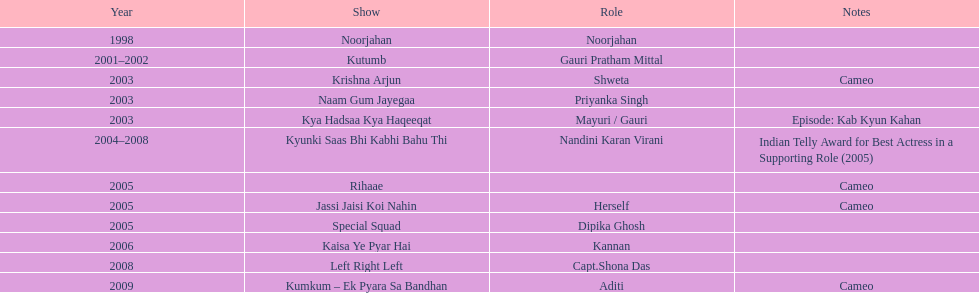How many performances took place in 2005? 3. 